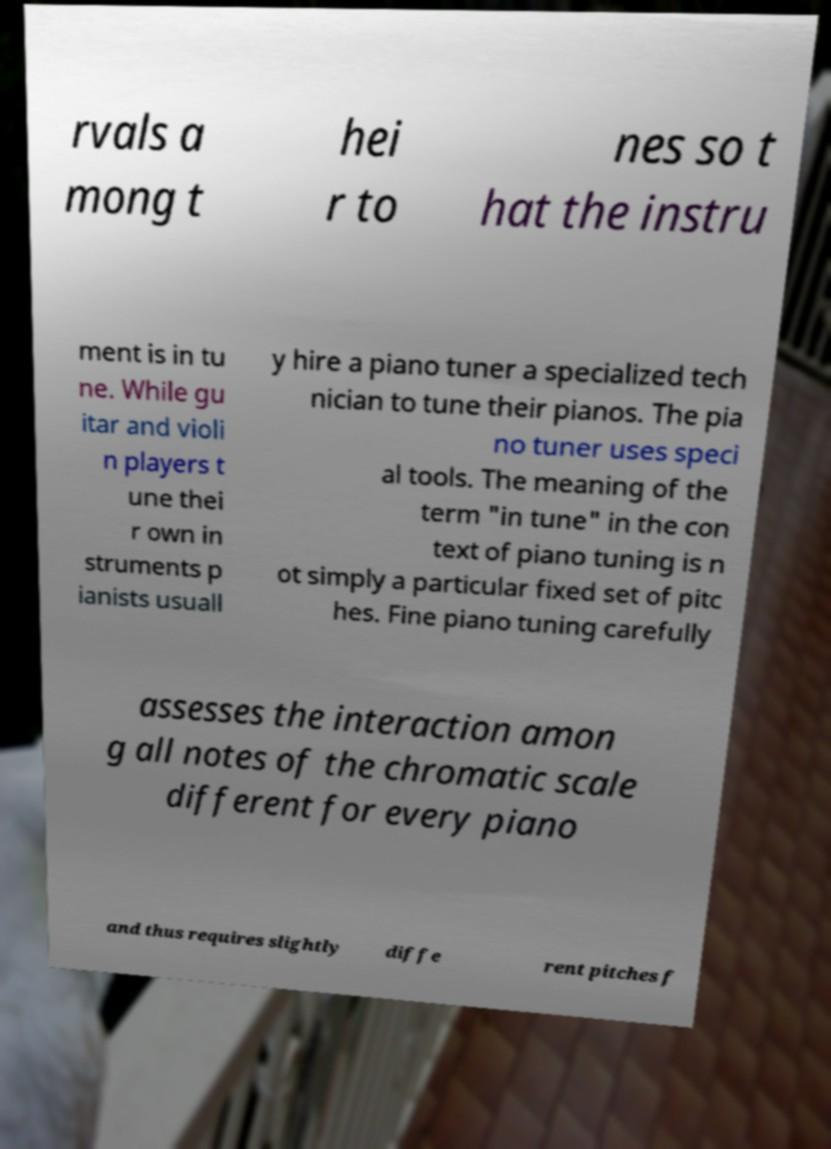I need the written content from this picture converted into text. Can you do that? rvals a mong t hei r to nes so t hat the instru ment is in tu ne. While gu itar and violi n players t une thei r own in struments p ianists usuall y hire a piano tuner a specialized tech nician to tune their pianos. The pia no tuner uses speci al tools. The meaning of the term "in tune" in the con text of piano tuning is n ot simply a particular fixed set of pitc hes. Fine piano tuning carefully assesses the interaction amon g all notes of the chromatic scale different for every piano and thus requires slightly diffe rent pitches f 